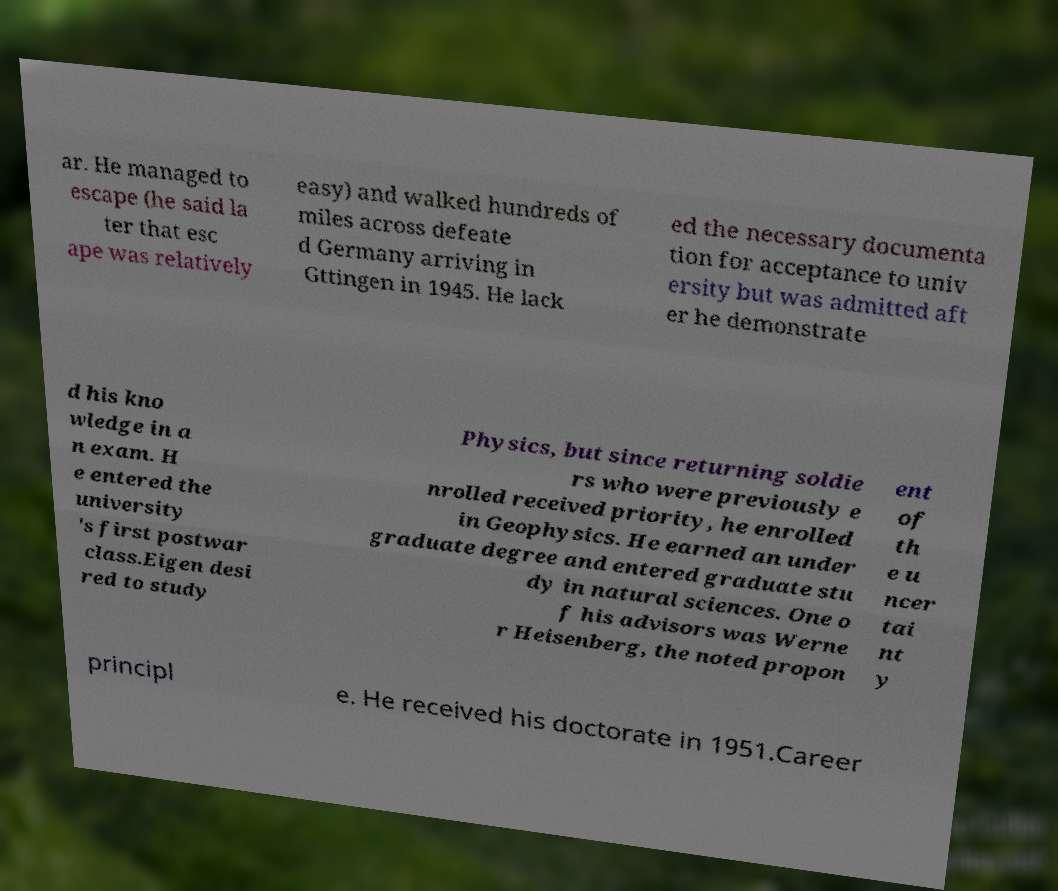What messages or text are displayed in this image? I need them in a readable, typed format. ar. He managed to escape (he said la ter that esc ape was relatively easy) and walked hundreds of miles across defeate d Germany arriving in Gttingen in 1945. He lack ed the necessary documenta tion for acceptance to univ ersity but was admitted aft er he demonstrate d his kno wledge in a n exam. H e entered the university 's first postwar class.Eigen desi red to study Physics, but since returning soldie rs who were previously e nrolled received priority, he enrolled in Geophysics. He earned an under graduate degree and entered graduate stu dy in natural sciences. One o f his advisors was Werne r Heisenberg, the noted propon ent of th e u ncer tai nt y principl e. He received his doctorate in 1951.Career 